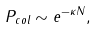Convert formula to latex. <formula><loc_0><loc_0><loc_500><loc_500>P _ { c o l } \sim e ^ { - \kappa N } ,</formula> 